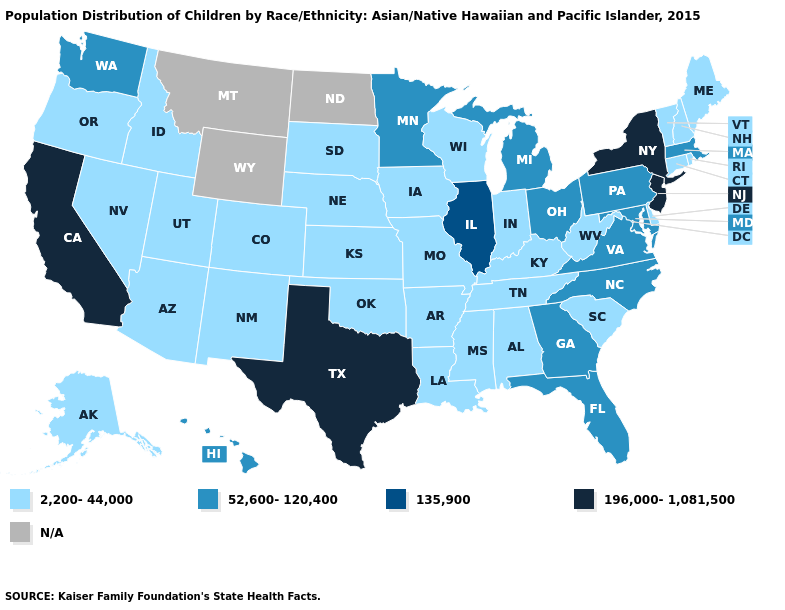Does the first symbol in the legend represent the smallest category?
Be succinct. Yes. What is the value of West Virginia?
Be succinct. 2,200-44,000. What is the value of Kentucky?
Short answer required. 2,200-44,000. What is the value of Maryland?
Keep it brief. 52,600-120,400. Name the states that have a value in the range 135,900?
Keep it brief. Illinois. Name the states that have a value in the range 52,600-120,400?
Keep it brief. Florida, Georgia, Hawaii, Maryland, Massachusetts, Michigan, Minnesota, North Carolina, Ohio, Pennsylvania, Virginia, Washington. Does Tennessee have the highest value in the USA?
Answer briefly. No. Name the states that have a value in the range N/A?
Keep it brief. Montana, North Dakota, Wyoming. Among the states that border Oregon , does Nevada have the highest value?
Short answer required. No. What is the value of Arkansas?
Be succinct. 2,200-44,000. Does Illinois have the lowest value in the USA?
Short answer required. No. What is the value of Rhode Island?
Give a very brief answer. 2,200-44,000. Name the states that have a value in the range 196,000-1,081,500?
Short answer required. California, New Jersey, New York, Texas. 